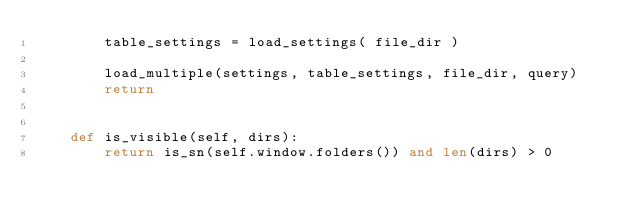<code> <loc_0><loc_0><loc_500><loc_500><_Python_>        table_settings = load_settings( file_dir )

        load_multiple(settings, table_settings, file_dir, query)
        return


    def is_visible(self, dirs):
        return is_sn(self.window.folders()) and len(dirs) > 0</code> 